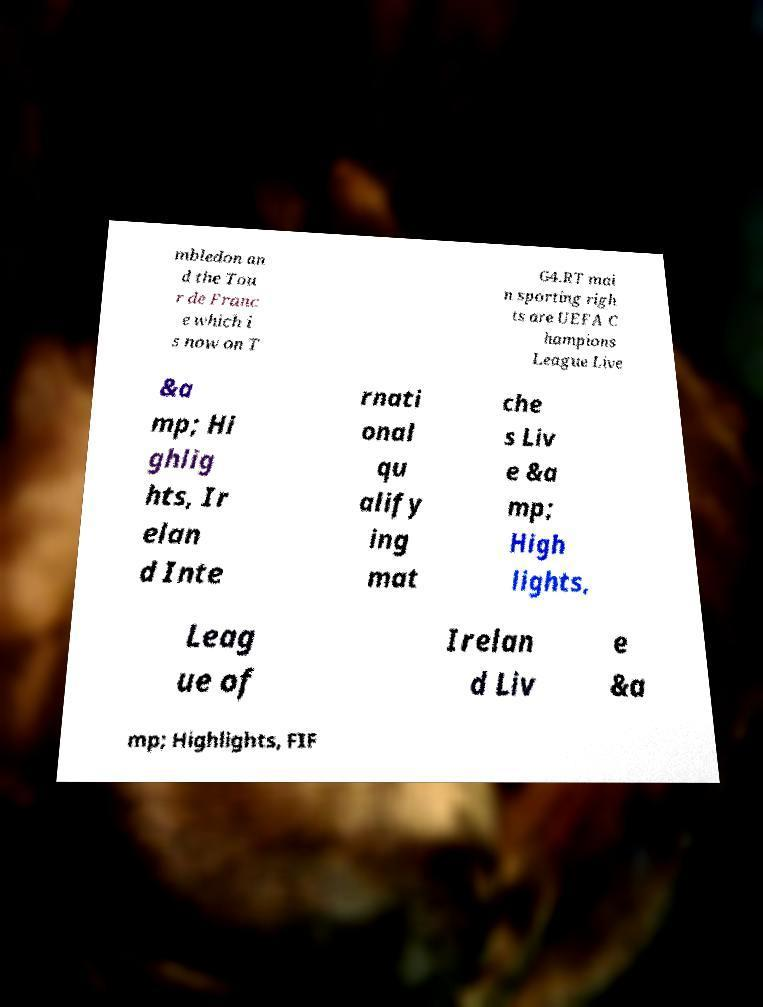For documentation purposes, I need the text within this image transcribed. Could you provide that? mbledon an d the Tou r de Franc e which i s now on T G4.RT mai n sporting righ ts are UEFA C hampions League Live &a mp; Hi ghlig hts, Ir elan d Inte rnati onal qu alify ing mat che s Liv e &a mp; High lights, Leag ue of Irelan d Liv e &a mp; Highlights, FIF 